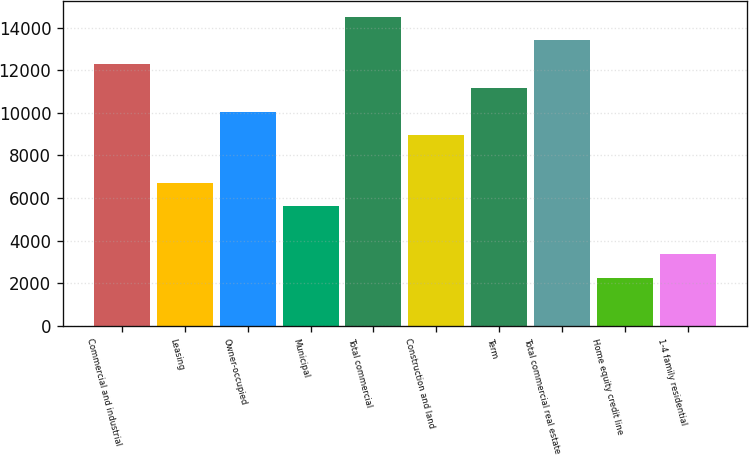<chart> <loc_0><loc_0><loc_500><loc_500><bar_chart><fcel>Commercial and industrial<fcel>Leasing<fcel>Owner-occupied<fcel>Municipal<fcel>Total commercial<fcel>Construction and land<fcel>Term<fcel>Total commercial real estate<fcel>Home equity credit line<fcel>1-4 family residential<nl><fcel>12291.1<fcel>6720.6<fcel>10062.9<fcel>5606.5<fcel>14519.3<fcel>8948.8<fcel>11177<fcel>13405.2<fcel>2264.2<fcel>3378.3<nl></chart> 